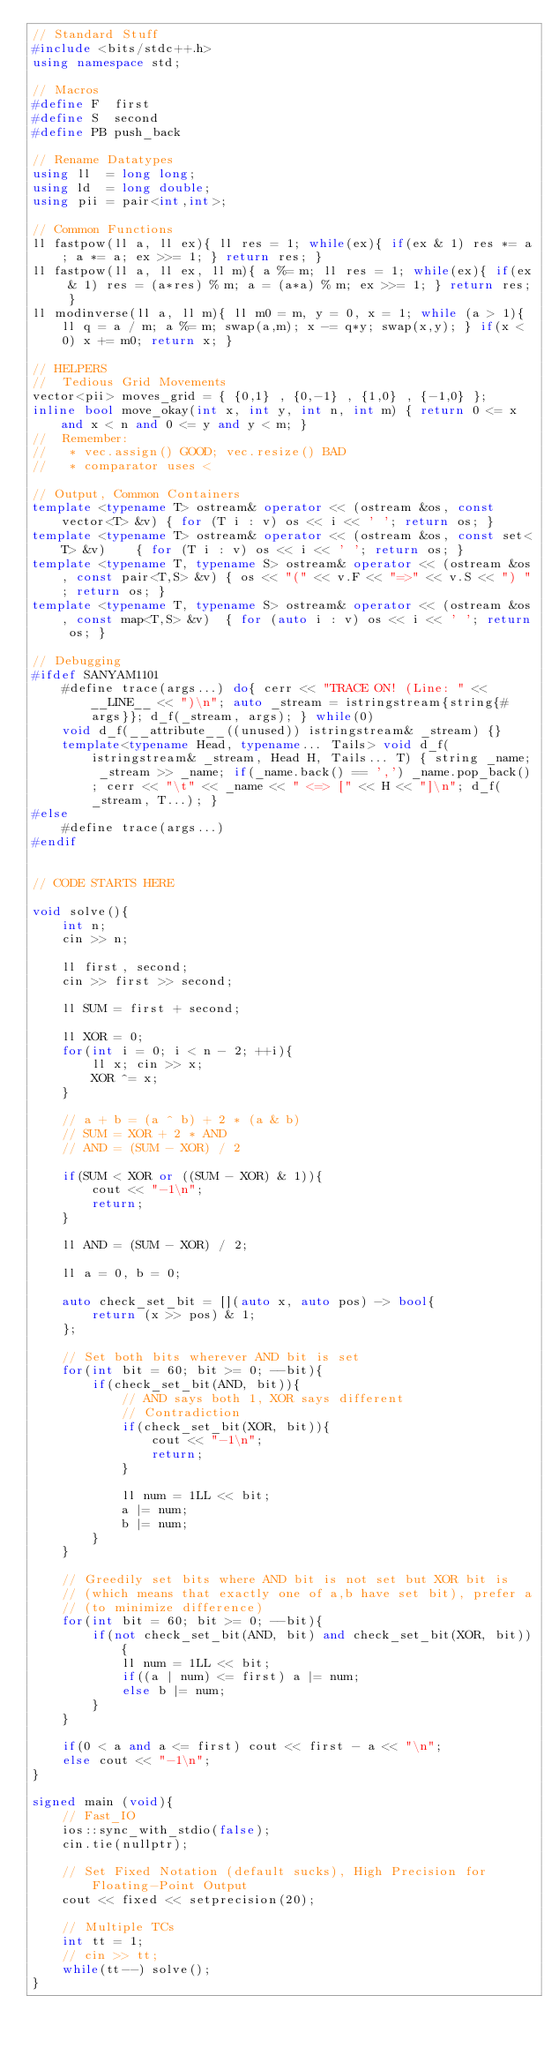Convert code to text. <code><loc_0><loc_0><loc_500><loc_500><_C++_>// Standard Stuff
#include <bits/stdc++.h>
using namespace std;

// Macros
#define F  first
#define S  second
#define PB push_back

// Rename Datatypes
using ll  = long long;
using ld  = long double;
using pii = pair<int,int>;

// Common Functions
ll fastpow(ll a, ll ex){ ll res = 1; while(ex){ if(ex & 1) res *= a; a *= a; ex >>= 1; } return res; }
ll fastpow(ll a, ll ex, ll m){ a %= m; ll res = 1; while(ex){ if(ex & 1) res = (a*res) % m; a = (a*a) % m; ex >>= 1; } return res; }
ll modinverse(ll a, ll m){ ll m0 = m, y = 0, x = 1; while (a > 1){ ll q = a / m; a %= m; swap(a,m); x -= q*y; swap(x,y); } if(x < 0) x += m0; return x; }

// HELPERS
//  Tedious Grid Movements
vector<pii> moves_grid = { {0,1} , {0,-1} , {1,0} , {-1,0} };
inline bool move_okay(int x, int y, int n, int m) { return 0 <= x and x < n and 0 <= y and y < m; }
//  Remember:
//   * vec.assign() GOOD; vec.resize() BAD
//   * comparator uses <

// Output, Common Containers
template <typename T> ostream& operator << (ostream &os, const vector<T> &v) { for (T i : v) os << i << ' '; return os; }
template <typename T> ostream& operator << (ostream &os, const set<T> &v)    { for (T i : v) os << i << ' '; return os; }
template <typename T, typename S> ostream& operator << (ostream &os, const pair<T,S> &v) { os << "(" << v.F << "=>" << v.S << ") "; return os; }
template <typename T, typename S> ostream& operator << (ostream &os, const map<T,S> &v)  { for (auto i : v) os << i << ' '; return os; }

// Debugging
#ifdef SANYAM1101
	#define trace(args...) do{ cerr << "TRACE ON! (Line: " << __LINE__ << ")\n"; auto _stream = istringstream{string{#args}}; d_f(_stream, args); } while(0)
	void d_f(__attribute__((unused)) istringstream& _stream) {}
	template<typename Head, typename... Tails> void d_f(istringstream& _stream, Head H, Tails... T) { string _name; _stream >> _name; if(_name.back() == ',') _name.pop_back(); cerr << "\t" << _name << " <=> [" << H << "]\n"; d_f(_stream, T...); }
#else
	#define trace(args...)
#endif


// CODE STARTS HERE

void solve(){
	int n;
	cin >> n;

	ll first, second;
	cin >> first >> second;

	ll SUM = first + second;

	ll XOR = 0;
	for(int i = 0; i < n - 2; ++i){
		ll x; cin >> x;
		XOR ^= x;
	}

	// a + b = (a ^ b) + 2 * (a & b)
	// SUM = XOR + 2 * AND
	// AND = (SUM - XOR) / 2

	if(SUM < XOR or ((SUM - XOR) & 1)){
		cout << "-1\n";
		return;
	}

	ll AND = (SUM - XOR) / 2;

	ll a = 0, b = 0;

	auto check_set_bit = [](auto x, auto pos) -> bool{
		return (x >> pos) & 1;
	};

	// Set both bits wherever AND bit is set
	for(int bit = 60; bit >= 0; --bit){
		if(check_set_bit(AND, bit)){
			// AND says both 1, XOR says different
			// Contradiction
			if(check_set_bit(XOR, bit)){
				cout << "-1\n";
				return;
			}

			ll num = 1LL << bit;
			a |= num;
			b |= num;
		}
	}

	// Greedily set bits where AND bit is not set but XOR bit is
	// (which means that exactly one of a,b have set bit), prefer a
	// (to minimize difference)
	for(int bit = 60; bit >= 0; --bit){
		if(not check_set_bit(AND, bit) and check_set_bit(XOR, bit)){
			ll num = 1LL << bit;
			if((a | num) <= first) a |= num;
			else b |= num;
		}
	}

	if(0 < a and a <= first) cout << first - a << "\n";
	else cout << "-1\n";
}

signed main (void){
	// Fast_IO
	ios::sync_with_stdio(false);
	cin.tie(nullptr);

	// Set Fixed Notation (default sucks), High Precision for Floating-Point Output
	cout << fixed << setprecision(20);

	// Multiple TCs
	int tt = 1;
	// cin >> tt;
	while(tt--) solve();
}
</code> 